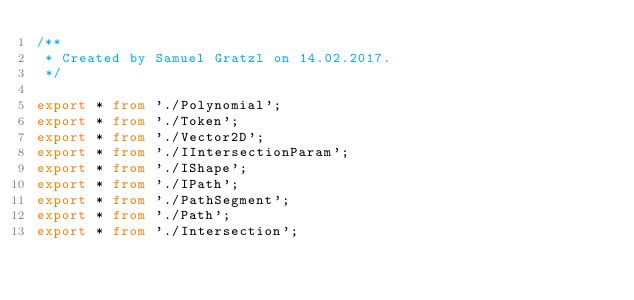<code> <loc_0><loc_0><loc_500><loc_500><_TypeScript_>/**
 * Created by Samuel Gratzl on 14.02.2017.
 */

export * from './Polynomial';
export * from './Token';
export * from './Vector2D';
export * from './IIntersectionParam';
export * from './IShape';
export * from './IPath';
export * from './PathSegment';
export * from './Path';
export * from './Intersection';
</code> 